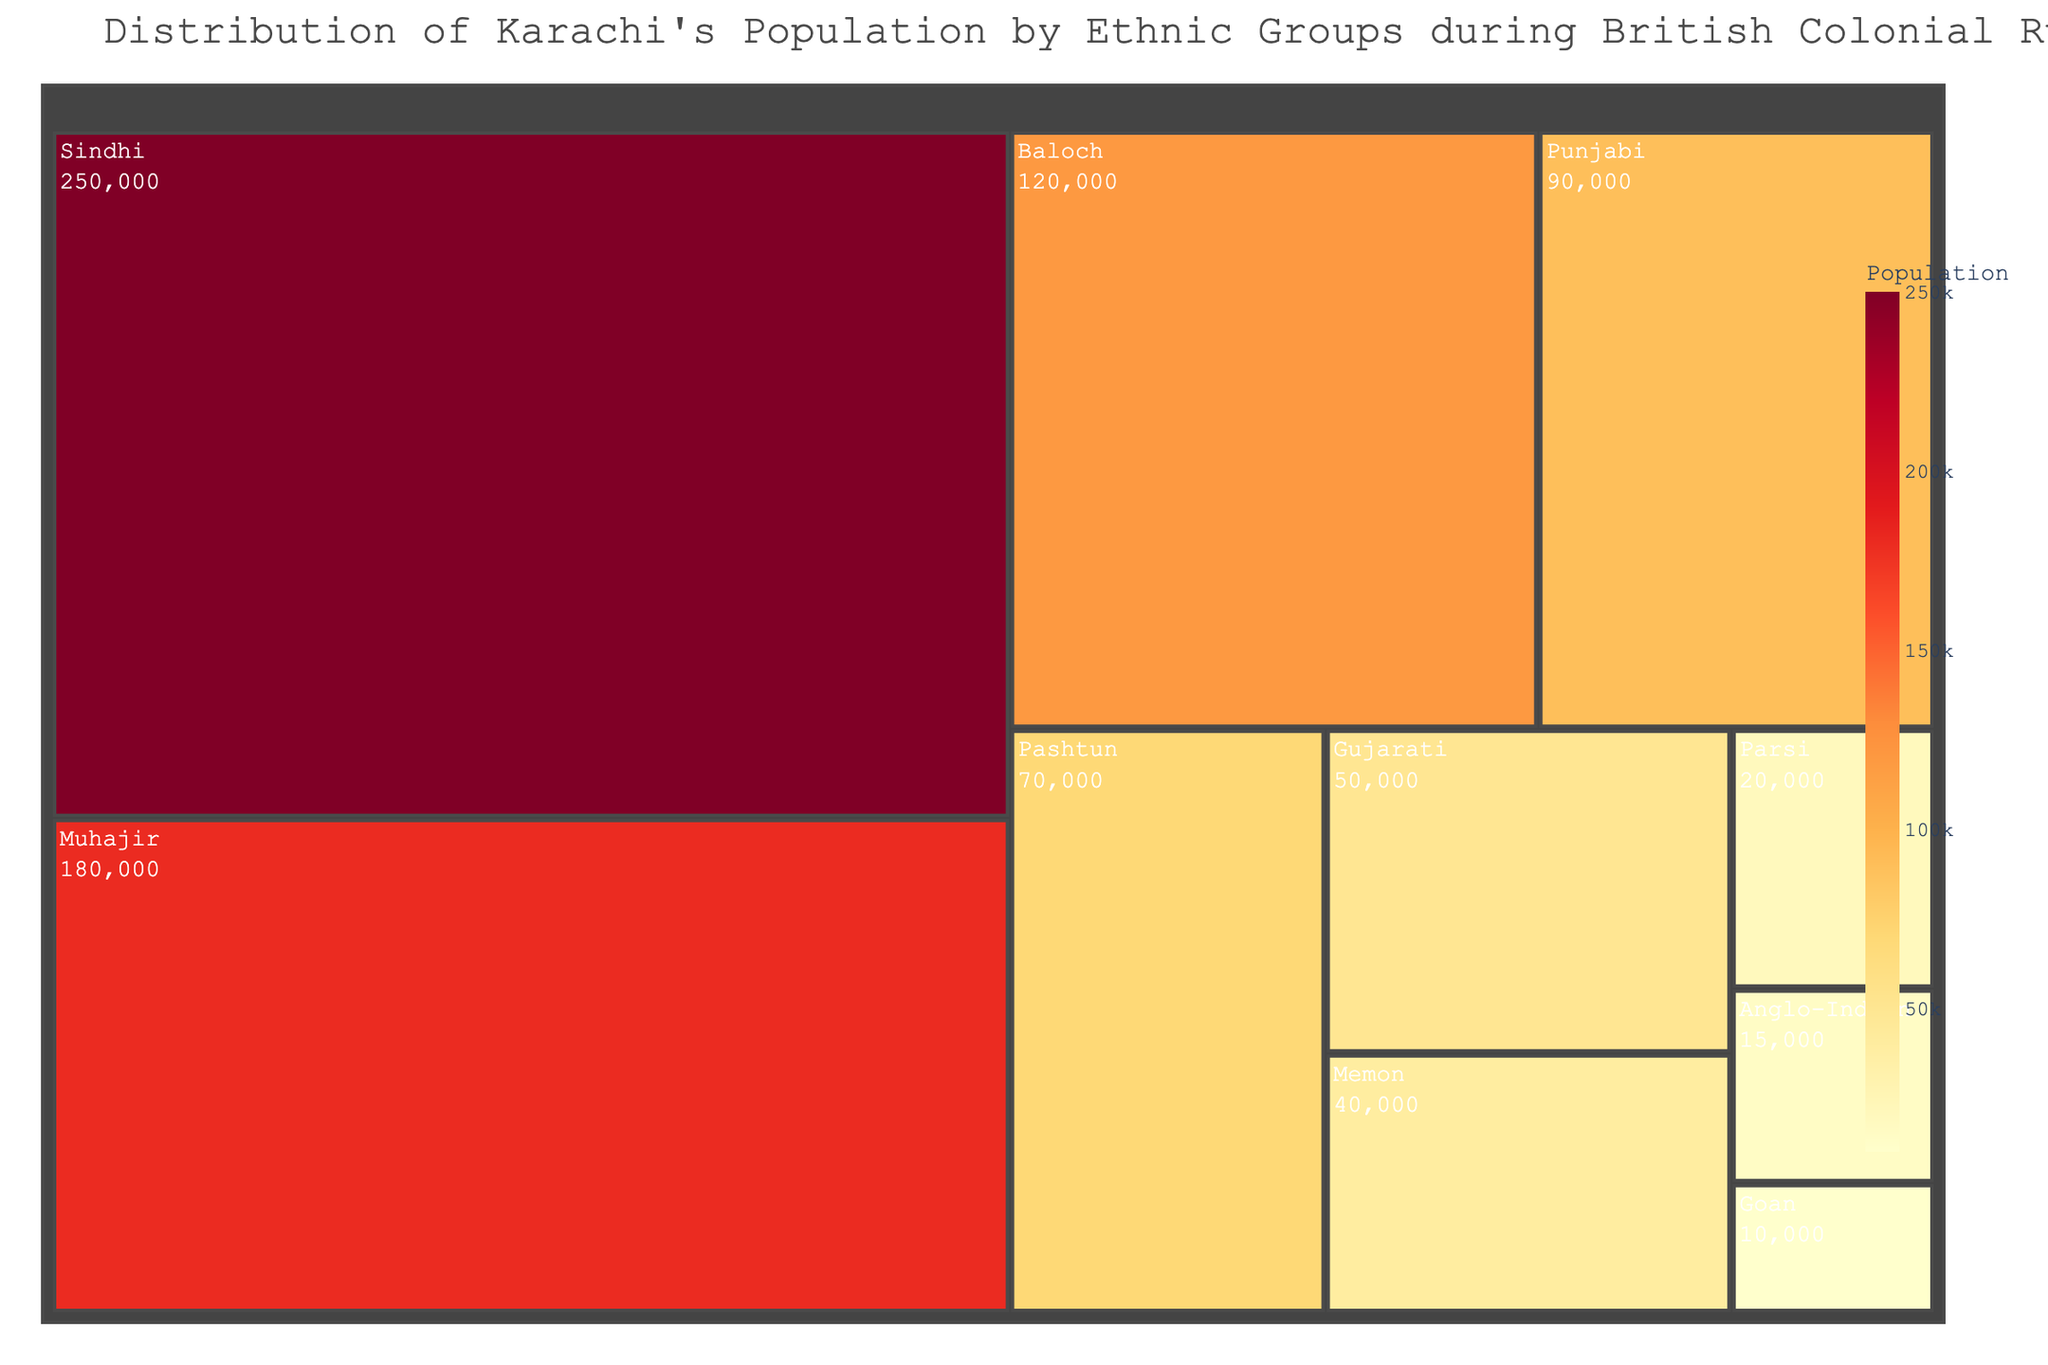Who represented the largest ethnic group in Karachi during British colonial rule based on this treemap? The largest ethnic group is represented by the largest segment in the treemap. The segment labeled "Sindhi" is the largest, indicating that Sindhis formed the largest ethnic group.
Answer: Sindhi What is the approximate population of the Anglo-Indian community? To find this, look at the segment labeled "Anglo-Indian" and check the displayed population value. The treemap shows a population of 15,000 for the Anglo-Indian community.
Answer: 15,000 How does the population of the Parsi community compare to the Goan community? Compare the segments labeled "Parsi" and "Goan" for their respective population values. The Parsi community has 20,000 people, while the Goan community has 10,000.
Answer: The Parsi community has a larger population than the Goan community What is the combined population of the Memon, Parsi, and Anglo-Indian communities? Sum the populations of the Memon (40,000), Parsi (20,000), and Anglo-Indian (15,000) communities. The total is 40,000 + 20,000 + 15,000 = 75,000.
Answer: 75,000 Which ethnic group is the smallest according to the treemap? Identify the smallest segment in the treemap, which is labeled "Goan." This group has a population of 10,000.
Answer: Goan How much larger is the population of the Muhajir group than the Baloch group? Subtract the Baloch population (120,000) from the Muhajir population (180,000). The difference is 180,000 - 120,000 = 60,000.
Answer: 60,000 If we combine the populations of the Baloch and Punjabi groups, do they exceed the Sindhi population? Sum the populations of the Baloch (120,000) and Punjabi (90,000) groups to get 120,000 + 90,000 = 210,000. The Sindhi population is 250,000, which is greater. Therefore, the combined population does not exceed the Sindhi population.
Answer: No What percentage of the total population does the Pashtun community constitute? First, calculate the total population by summing all ethnic groups: 250,000 + 180,000 + 120,000 + 90,000 + 70,000 + 50,000 + 40,000 + 20,000 + 15,000 + 10,000 = 845,000. Then find the percentage: (70,000 / 845,000) * 100 ≈ 8.28%.
Answer: 8.28% Is the population of the Gujarati group closer to the Pashtun group or the Memon group? The Gujarati population is 50,000. The difference between Gujarati and Pashtun populations is 70,000 - 50,000 = 20,000. The difference between Gujarati and Memon populations is 50,000 - 40,000 = 10,000. Hence, the Gujarati population is closer to the Memon group.
Answer: Memon 